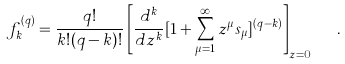<formula> <loc_0><loc_0><loc_500><loc_500>f _ { k } ^ { ( q ) } = \frac { q ! } { k ! ( q - k ) ! } \left [ \frac { d ^ { k } } { d z ^ { k } } [ 1 + \sum _ { \mu = 1 } ^ { \infty } z ^ { \mu } s _ { \mu } ] ^ { ( q - k ) } \right ] _ { z = 0 } \ \ .</formula> 